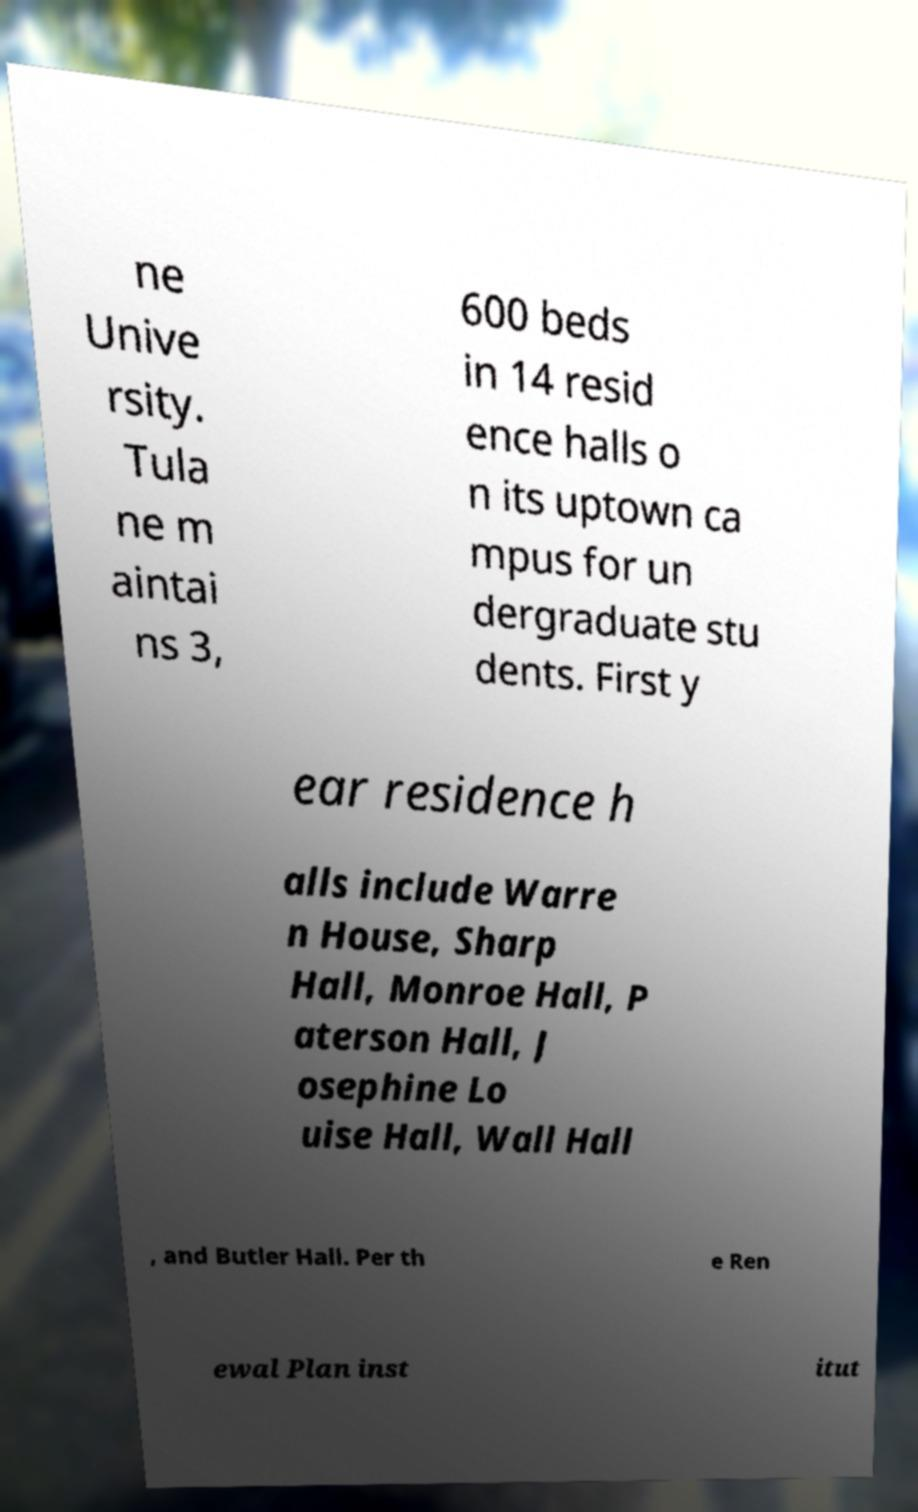Please read and relay the text visible in this image. What does it say? ne Unive rsity. Tula ne m aintai ns 3, 600 beds in 14 resid ence halls o n its uptown ca mpus for un dergraduate stu dents. First y ear residence h alls include Warre n House, Sharp Hall, Monroe Hall, P aterson Hall, J osephine Lo uise Hall, Wall Hall , and Butler Hall. Per th e Ren ewal Plan inst itut 